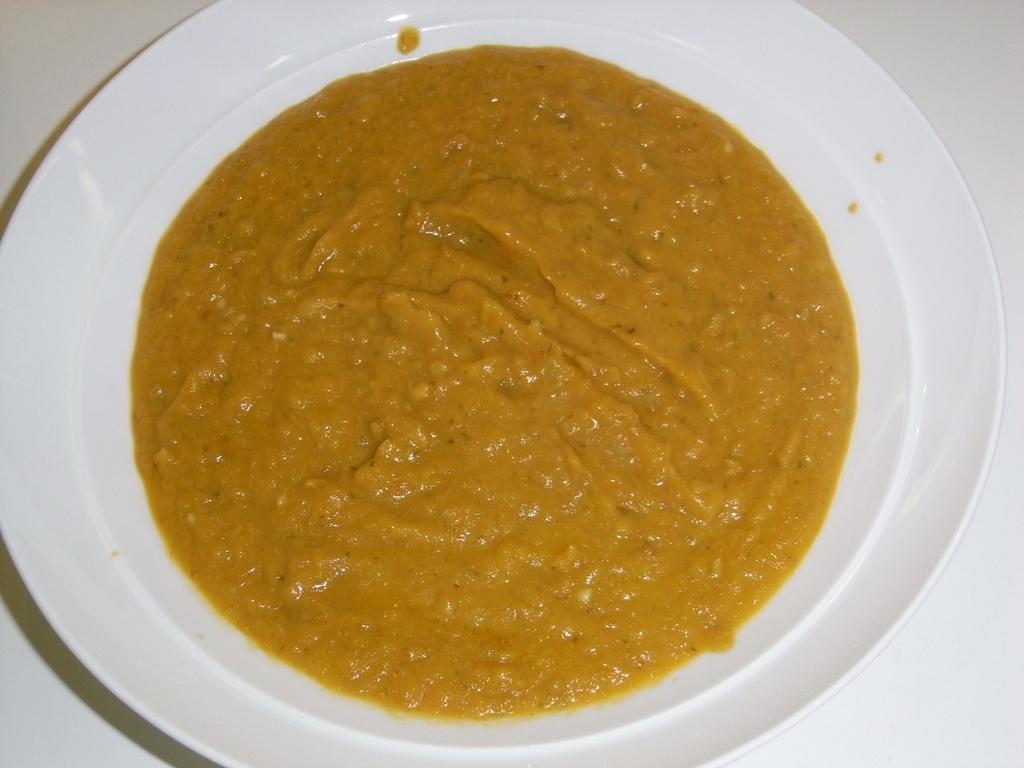Can you describe this image briefly? In this image we can see food in a plate which is on a white color platform. 